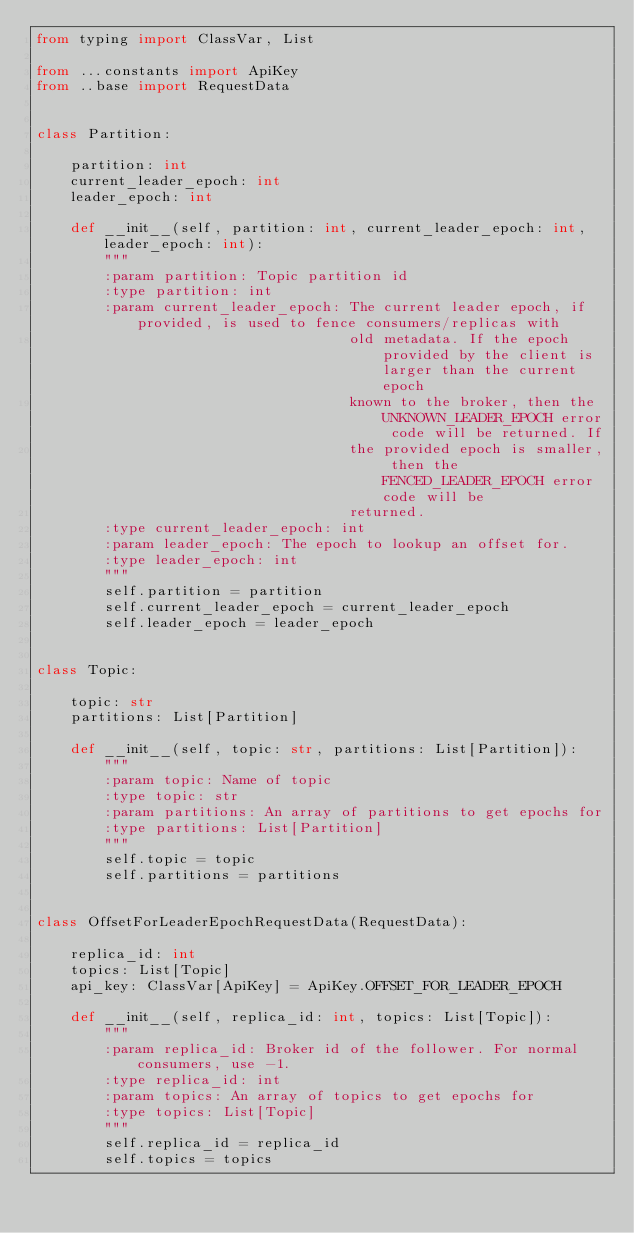Convert code to text. <code><loc_0><loc_0><loc_500><loc_500><_Python_>from typing import ClassVar, List

from ...constants import ApiKey
from ..base import RequestData


class Partition:

    partition: int
    current_leader_epoch: int
    leader_epoch: int

    def __init__(self, partition: int, current_leader_epoch: int, leader_epoch: int):
        """
        :param partition: Topic partition id
        :type partition: int
        :param current_leader_epoch: The current leader epoch, if provided, is used to fence consumers/replicas with
                                     old metadata. If the epoch provided by the client is larger than the current epoch
                                     known to the broker, then the UNKNOWN_LEADER_EPOCH error code will be returned. If
                                     the provided epoch is smaller, then the FENCED_LEADER_EPOCH error code will be
                                     returned.
        :type current_leader_epoch: int
        :param leader_epoch: The epoch to lookup an offset for.
        :type leader_epoch: int
        """
        self.partition = partition
        self.current_leader_epoch = current_leader_epoch
        self.leader_epoch = leader_epoch


class Topic:

    topic: str
    partitions: List[Partition]

    def __init__(self, topic: str, partitions: List[Partition]):
        """
        :param topic: Name of topic
        :type topic: str
        :param partitions: An array of partitions to get epochs for
        :type partitions: List[Partition]
        """
        self.topic = topic
        self.partitions = partitions


class OffsetForLeaderEpochRequestData(RequestData):

    replica_id: int
    topics: List[Topic]
    api_key: ClassVar[ApiKey] = ApiKey.OFFSET_FOR_LEADER_EPOCH

    def __init__(self, replica_id: int, topics: List[Topic]):
        """
        :param replica_id: Broker id of the follower. For normal consumers, use -1.
        :type replica_id: int
        :param topics: An array of topics to get epochs for
        :type topics: List[Topic]
        """
        self.replica_id = replica_id
        self.topics = topics
</code> 